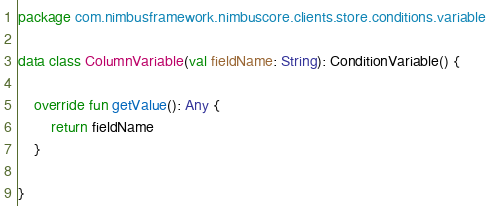Convert code to text. <code><loc_0><loc_0><loc_500><loc_500><_Kotlin_>package com.nimbusframework.nimbuscore.clients.store.conditions.variable

data class ColumnVariable(val fieldName: String): ConditionVariable() {

    override fun getValue(): Any {
        return fieldName
    }

}
</code> 